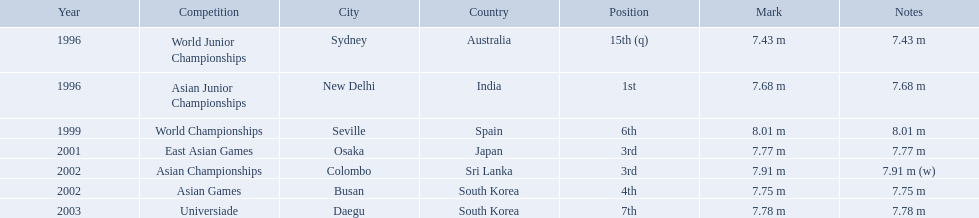Could you parse the entire table? {'header': ['Year', 'Competition', 'City', 'Country', 'Position', 'Mark', 'Notes'], 'rows': [['1996', 'World Junior Championships', 'Sydney', 'Australia', '15th (q)', '7.43 m', '7.43 m'], ['1996', 'Asian Junior Championships', 'New Delhi', 'India', '1st', '7.68 m', '7.68 m'], ['1999', 'World Championships', 'Seville', 'Spain', '6th', '8.01 m', '8.01 m'], ['2001', 'East Asian Games', 'Osaka', 'Japan', '3rd', '7.77 m', '7.77 m'], ['2002', 'Asian Championships', 'Colombo', 'Sri Lanka', '3rd', '7.91 m', '7.91 m (w)'], ['2002', 'Asian Games', 'Busan', 'South Korea', '4th', '7.75 m', '7.75 m'], ['2003', 'Universiade', 'Daegu', 'South Korea', '7th', '7.78 m', '7.78 m']]} Which competition did huang le achieve 3rd place? East Asian Games. Which competition did he achieve 4th place? Asian Games. When did he achieve 1st place? Asian Junior Championships. What are all of the competitions? World Junior Championships, Asian Junior Championships, World Championships, East Asian Games, Asian Championships, Asian Games, Universiade. What was his positions in these competitions? 15th (q), 1st, 6th, 3rd, 3rd, 4th, 7th. And during which competition did he reach 1st place? Asian Junior Championships. What rankings has this competitor placed through the competitions? 15th (q), 1st, 6th, 3rd, 3rd, 4th, 7th. Parse the full table in json format. {'header': ['Year', 'Competition', 'City', 'Country', 'Position', 'Mark', 'Notes'], 'rows': [['1996', 'World Junior Championships', 'Sydney', 'Australia', '15th (q)', '7.43 m', '7.43 m'], ['1996', 'Asian Junior Championships', 'New Delhi', 'India', '1st', '7.68 m', '7.68 m'], ['1999', 'World Championships', 'Seville', 'Spain', '6th', '8.01 m', '8.01 m'], ['2001', 'East Asian Games', 'Osaka', 'Japan', '3rd', '7.77 m', '7.77 m'], ['2002', 'Asian Championships', 'Colombo', 'Sri Lanka', '3rd', '7.91 m', '7.91 m (w)'], ['2002', 'Asian Games', 'Busan', 'South Korea', '4th', '7.75 m', '7.75 m'], ['2003', 'Universiade', 'Daegu', 'South Korea', '7th', '7.78 m', '7.78 m']]} In which competition did the competitor place 1st? Asian Junior Championships. What are the competitions that huang le participated in? World Junior Championships, Asian Junior Championships, World Championships, East Asian Games, Asian Championships, Asian Games, Universiade. Which competitions did he participate in 2002 Asian Championships, Asian Games. What are the lengths of his jumps that year? 7.91 m (w), 7.75 m. What is the longest length of a jump? 7.91 m (w). What competitions did huang le compete in? World Junior Championships, Asian Junior Championships, World Championships, East Asian Games, Asian Championships, Asian Games, Universiade. What distances did he achieve in these competitions? 7.43 m, 7.68 m, 8.01 m, 7.77 m, 7.91 m (w), 7.75 m, 7.78 m. Which of these distances was the longest? 7.91 m (w). 